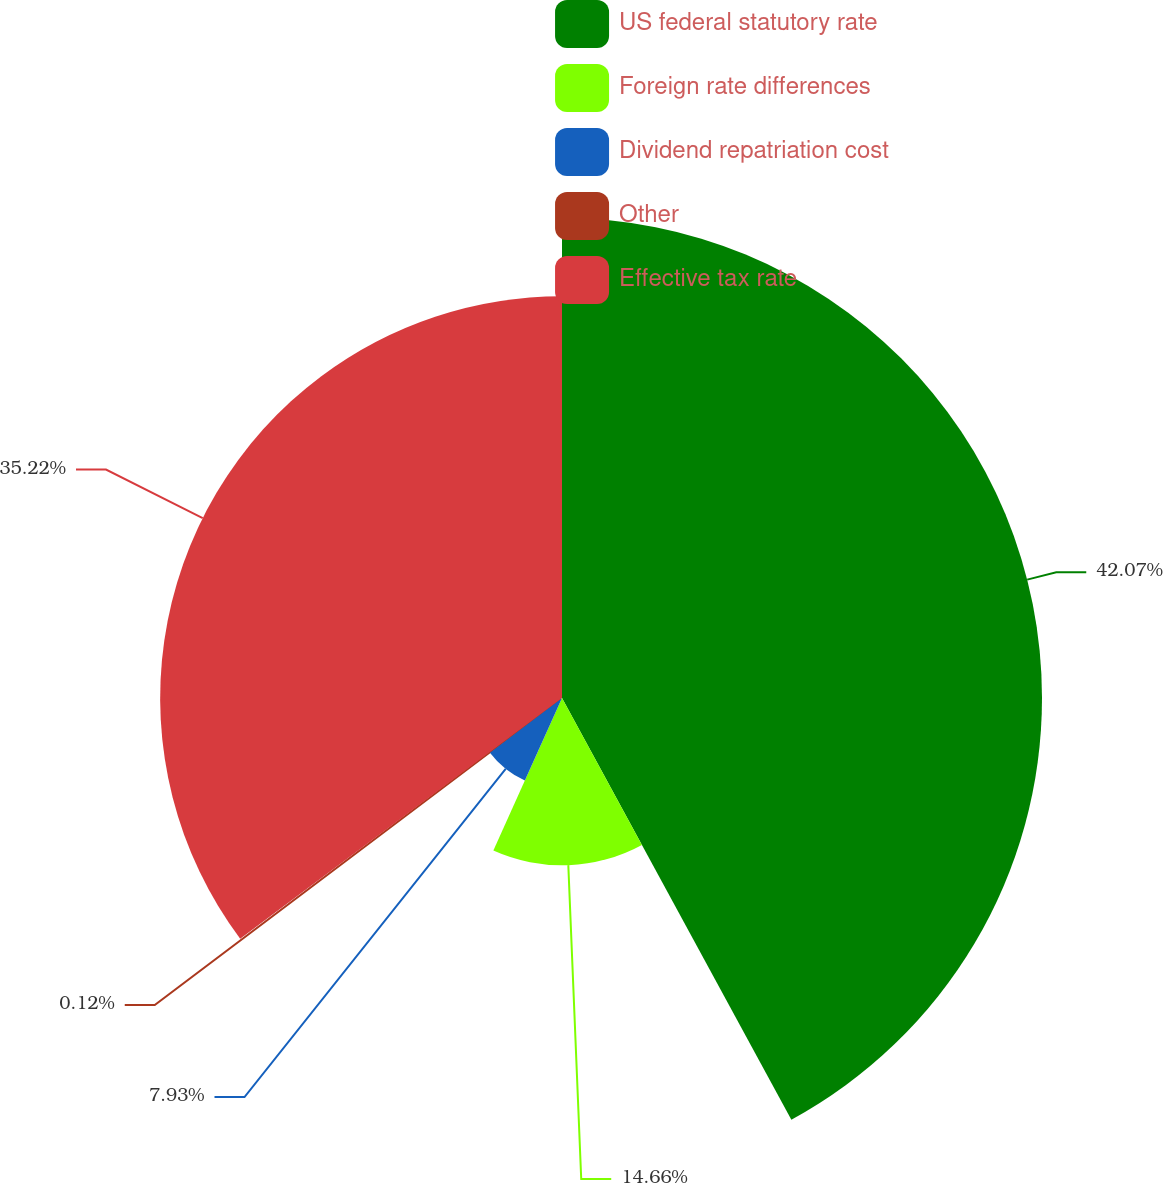<chart> <loc_0><loc_0><loc_500><loc_500><pie_chart><fcel>US federal statutory rate<fcel>Foreign rate differences<fcel>Dividend repatriation cost<fcel>Other<fcel>Effective tax rate<nl><fcel>42.07%<fcel>14.66%<fcel>7.93%<fcel>0.12%<fcel>35.22%<nl></chart> 